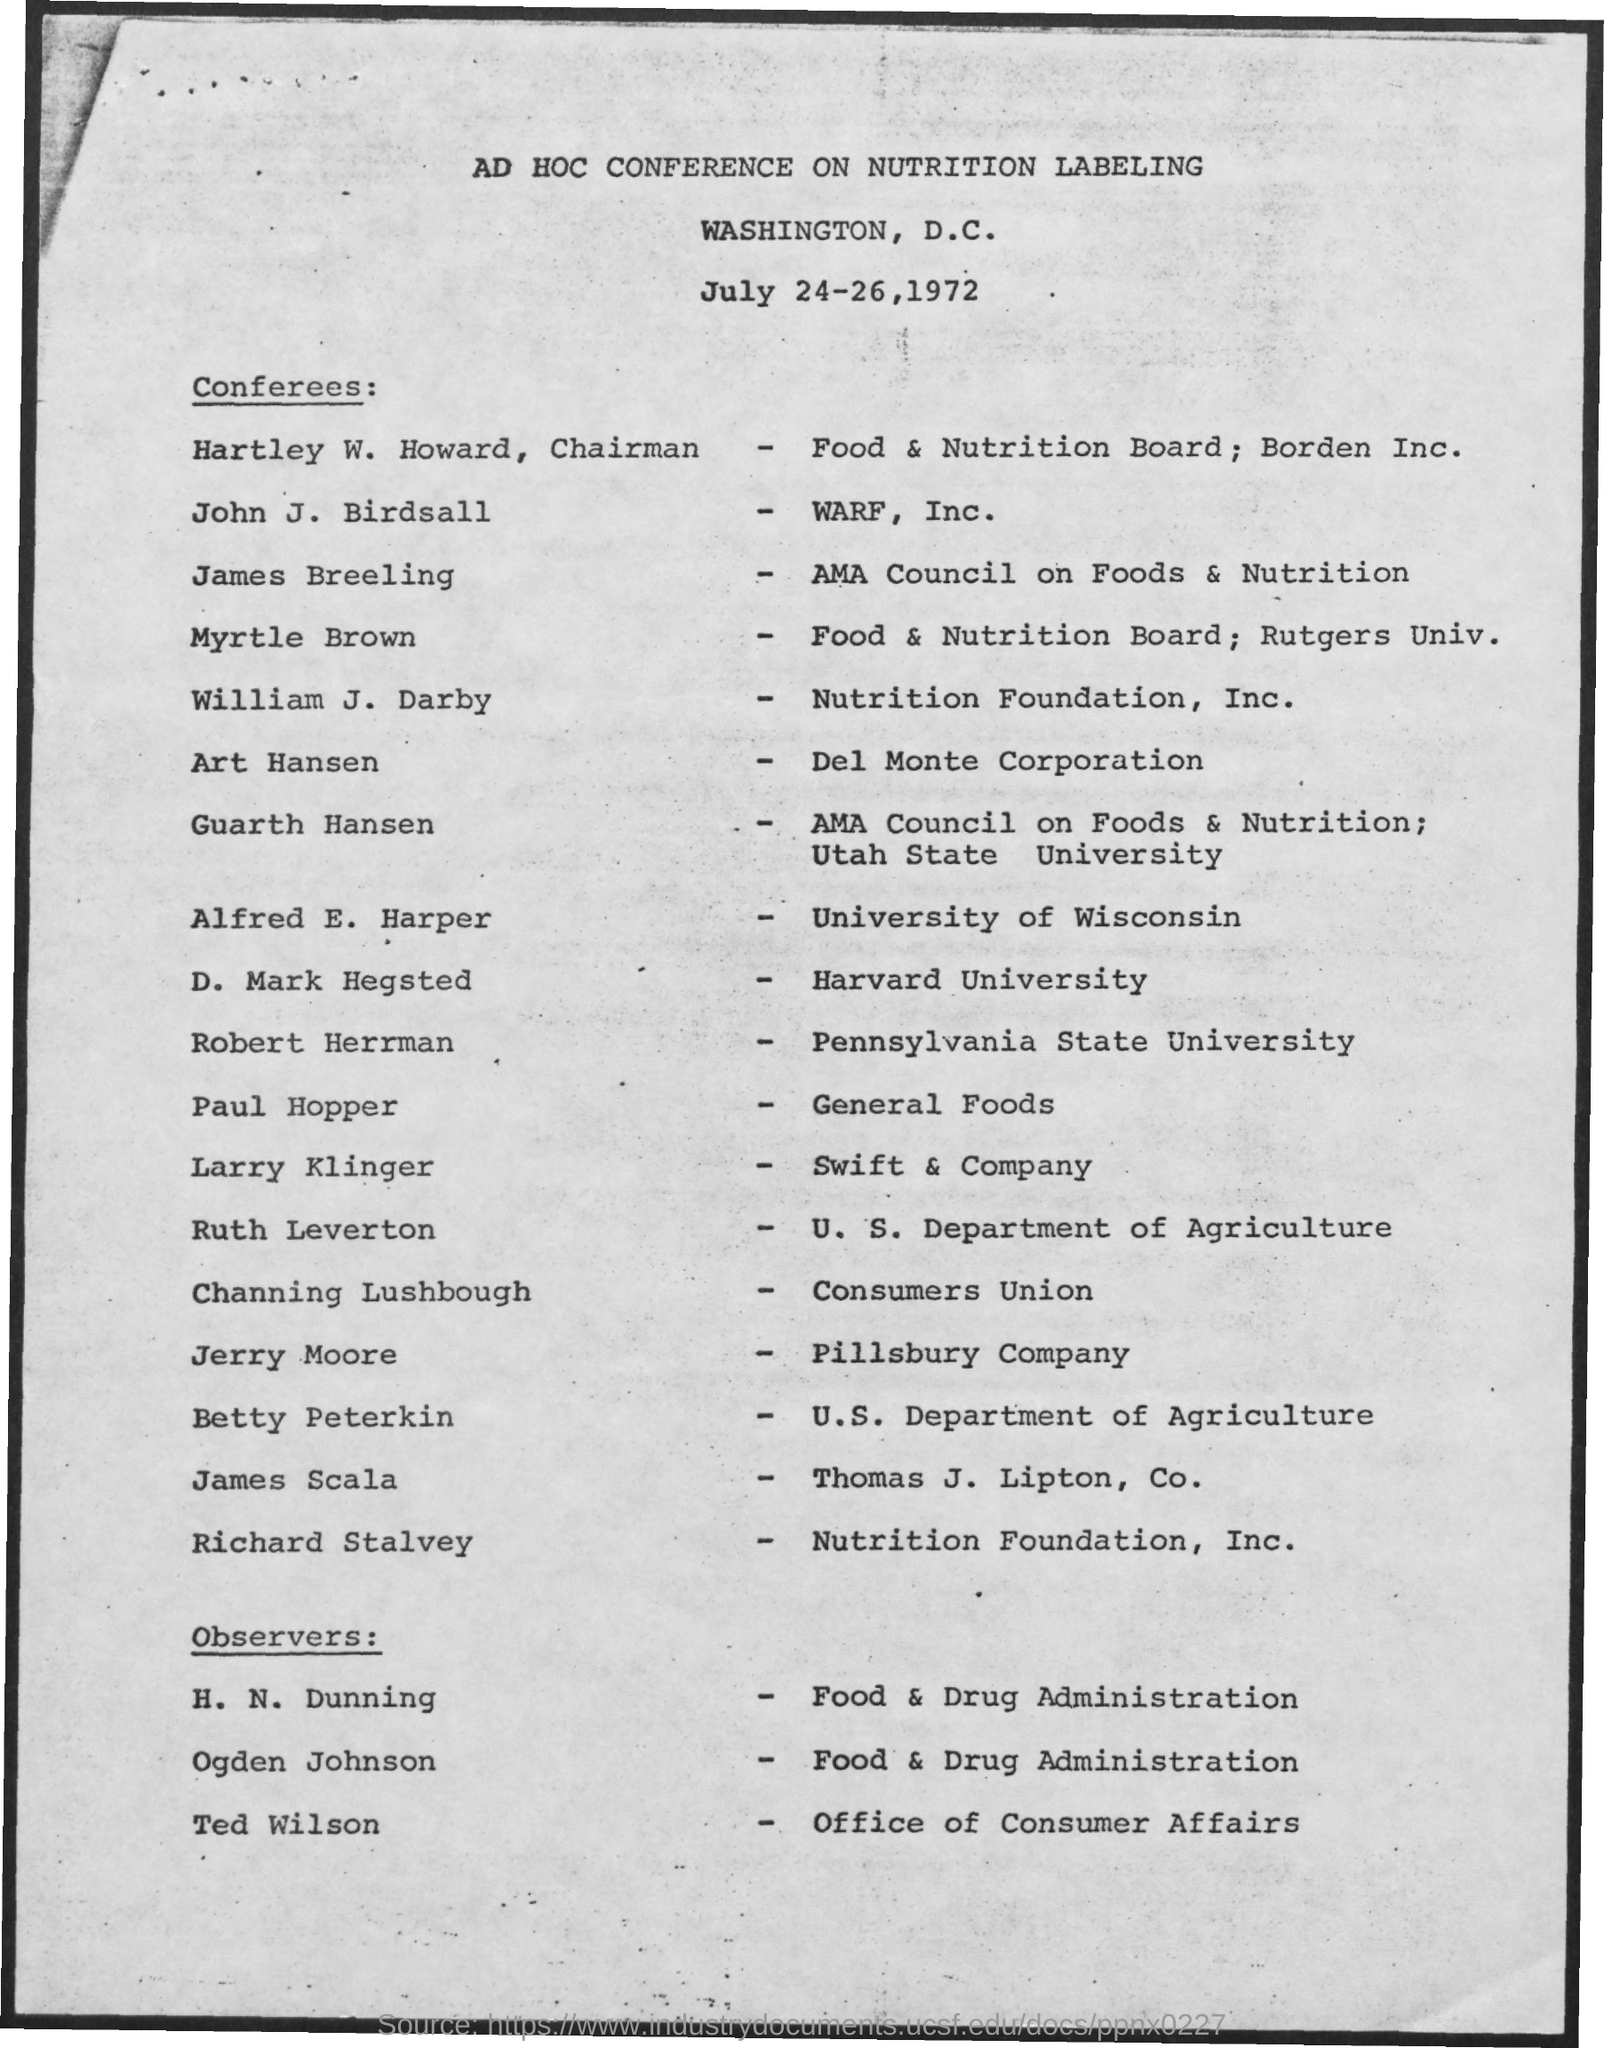To which company jerry moore belongs to ?
Your answer should be compact. Pillsbury Company. To which company james breeling belongs to ?
Your response must be concise. AMA Council on Foods & Nutrition. To which university d,mark hegsted belongs to ?
Provide a succinct answer. Harvard University. Who is the observer of office of consumer affairs ?
Make the answer very short. Ted wilson. Where is the conference on nutrition labeling was held ?
Your answer should be very brief. Washington , d.c. To which department betty peterkin belongs to ?
Offer a terse response. U.S. Department of agriculture. 